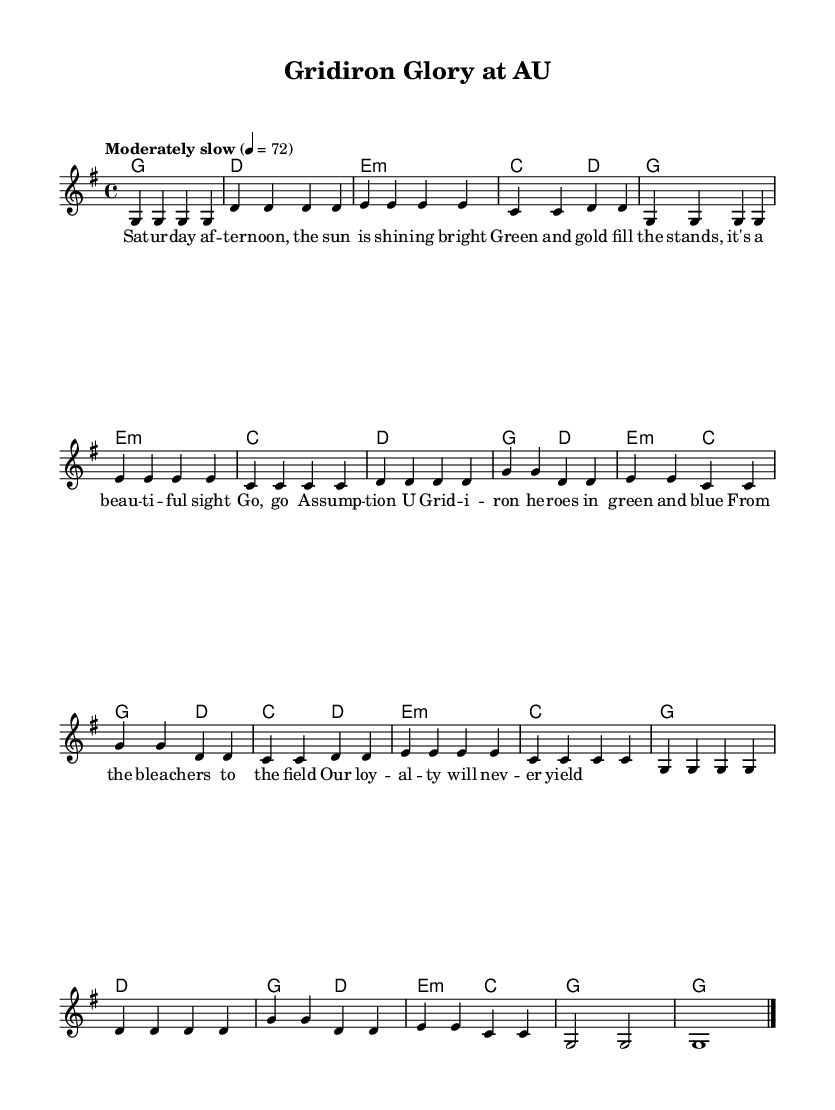What is the key signature of this music? The key signature is G major, which has one sharp (F#). This is indicated at the beginning of the staff where the key signature is placed.
Answer: G major What is the time signature of this music? The time signature is 4/4, which means there are four beats in each measure with a quarter note receiving one beat. This is indicated at the beginning of the score next to the clef.
Answer: 4/4 What is the tempo marking for the piece? The tempo marking is "Moderately slow" with a metronome marking of 72 beats per minute, which indicates how fast or slow the music should be played. This is specified in the tempo instruction at the start of the score.
Answer: Moderately slow How many measures are in the chorus section? The chorus section consists of four measures, as can be seen by counting the measures labeled "Chorus" in the music. Each line in the chorus has a specific number of beats that fit into these measures.
Answer: 4 What is the mood expressed in the lyrics of the bridge? The mood expressed in the lyrics of the bridge is one of loyalty and strength, as indicated by phrases like "Our loyalty will never yield." This suggests a feeling of commitment and determination surrounding college football culture.
Answer: Loyalty What is the primary theme of the song? The primary theme of the song revolves around celebrating college football culture and the spirit of the Assumption University football team, as evidenced by the lyrics and overall tone of the music.
Answer: College football culture What chords are used in the verse section? The chords used in the verse section are G, E minor, C, and D. These chords are played in sequence throughout the verse as indicated in the harmonies part below the melody.
Answer: G, E minor, C, D 